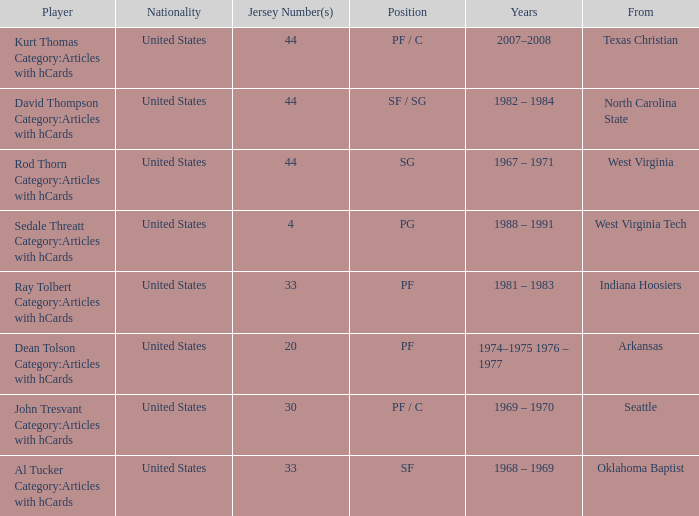What was the highest jersey number for the player from oklahoma baptist? 33.0. 